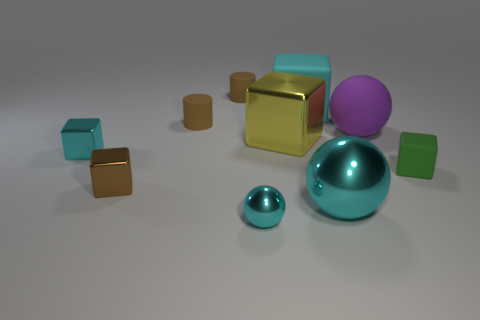Subtract all small cyan shiny blocks. How many blocks are left? 4 Subtract all brown cubes. How many cubes are left? 4 Subtract all purple cubes. Subtract all cyan balls. How many cubes are left? 5 Subtract all spheres. How many objects are left? 7 Subtract 1 brown cylinders. How many objects are left? 9 Subtract all small cyan balls. Subtract all tiny cyan metal cubes. How many objects are left? 8 Add 7 big yellow objects. How many big yellow objects are left? 8 Add 6 big objects. How many big objects exist? 10 